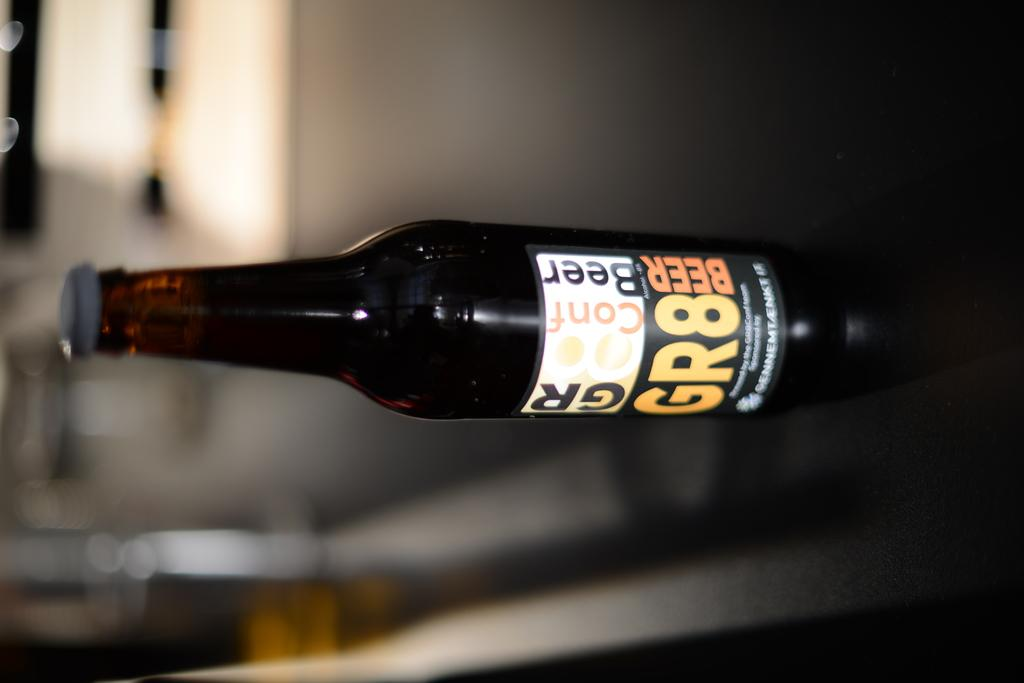<image>
Describe the image concisely. A bottle that has GR8 Beer written on the label. 